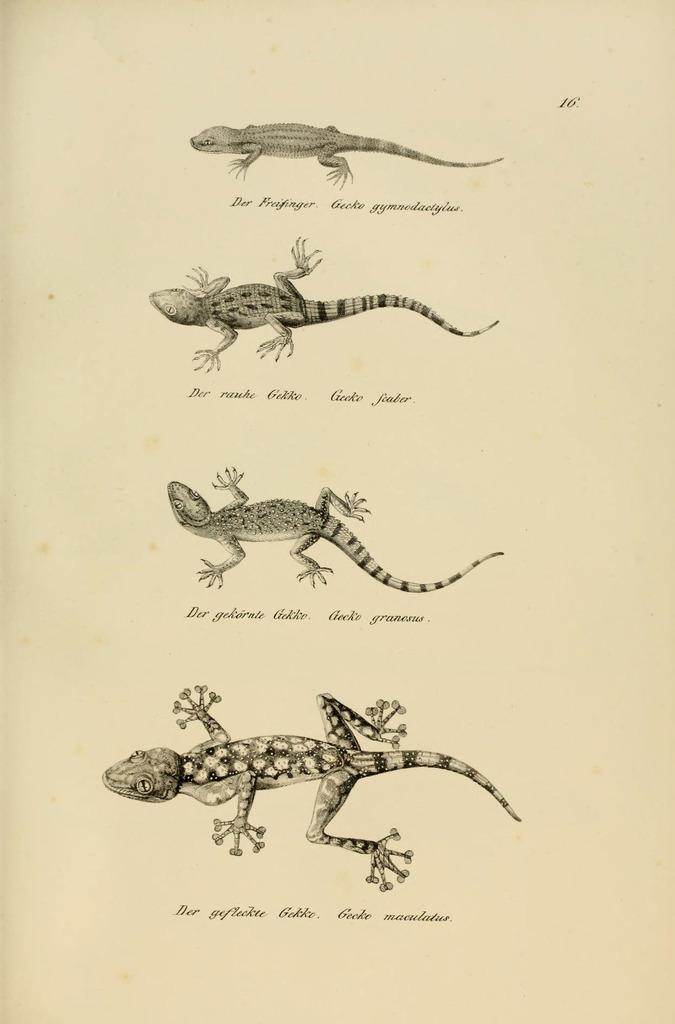What type of animals are featured in the image? There are reptiles in the image. What additional information is provided about each reptile? There is text under each reptile in the image. What type of dinosaurs can be seen at the airport in the image? There are no dinosaurs or airports present in the image; it features reptiles with text underneath. 